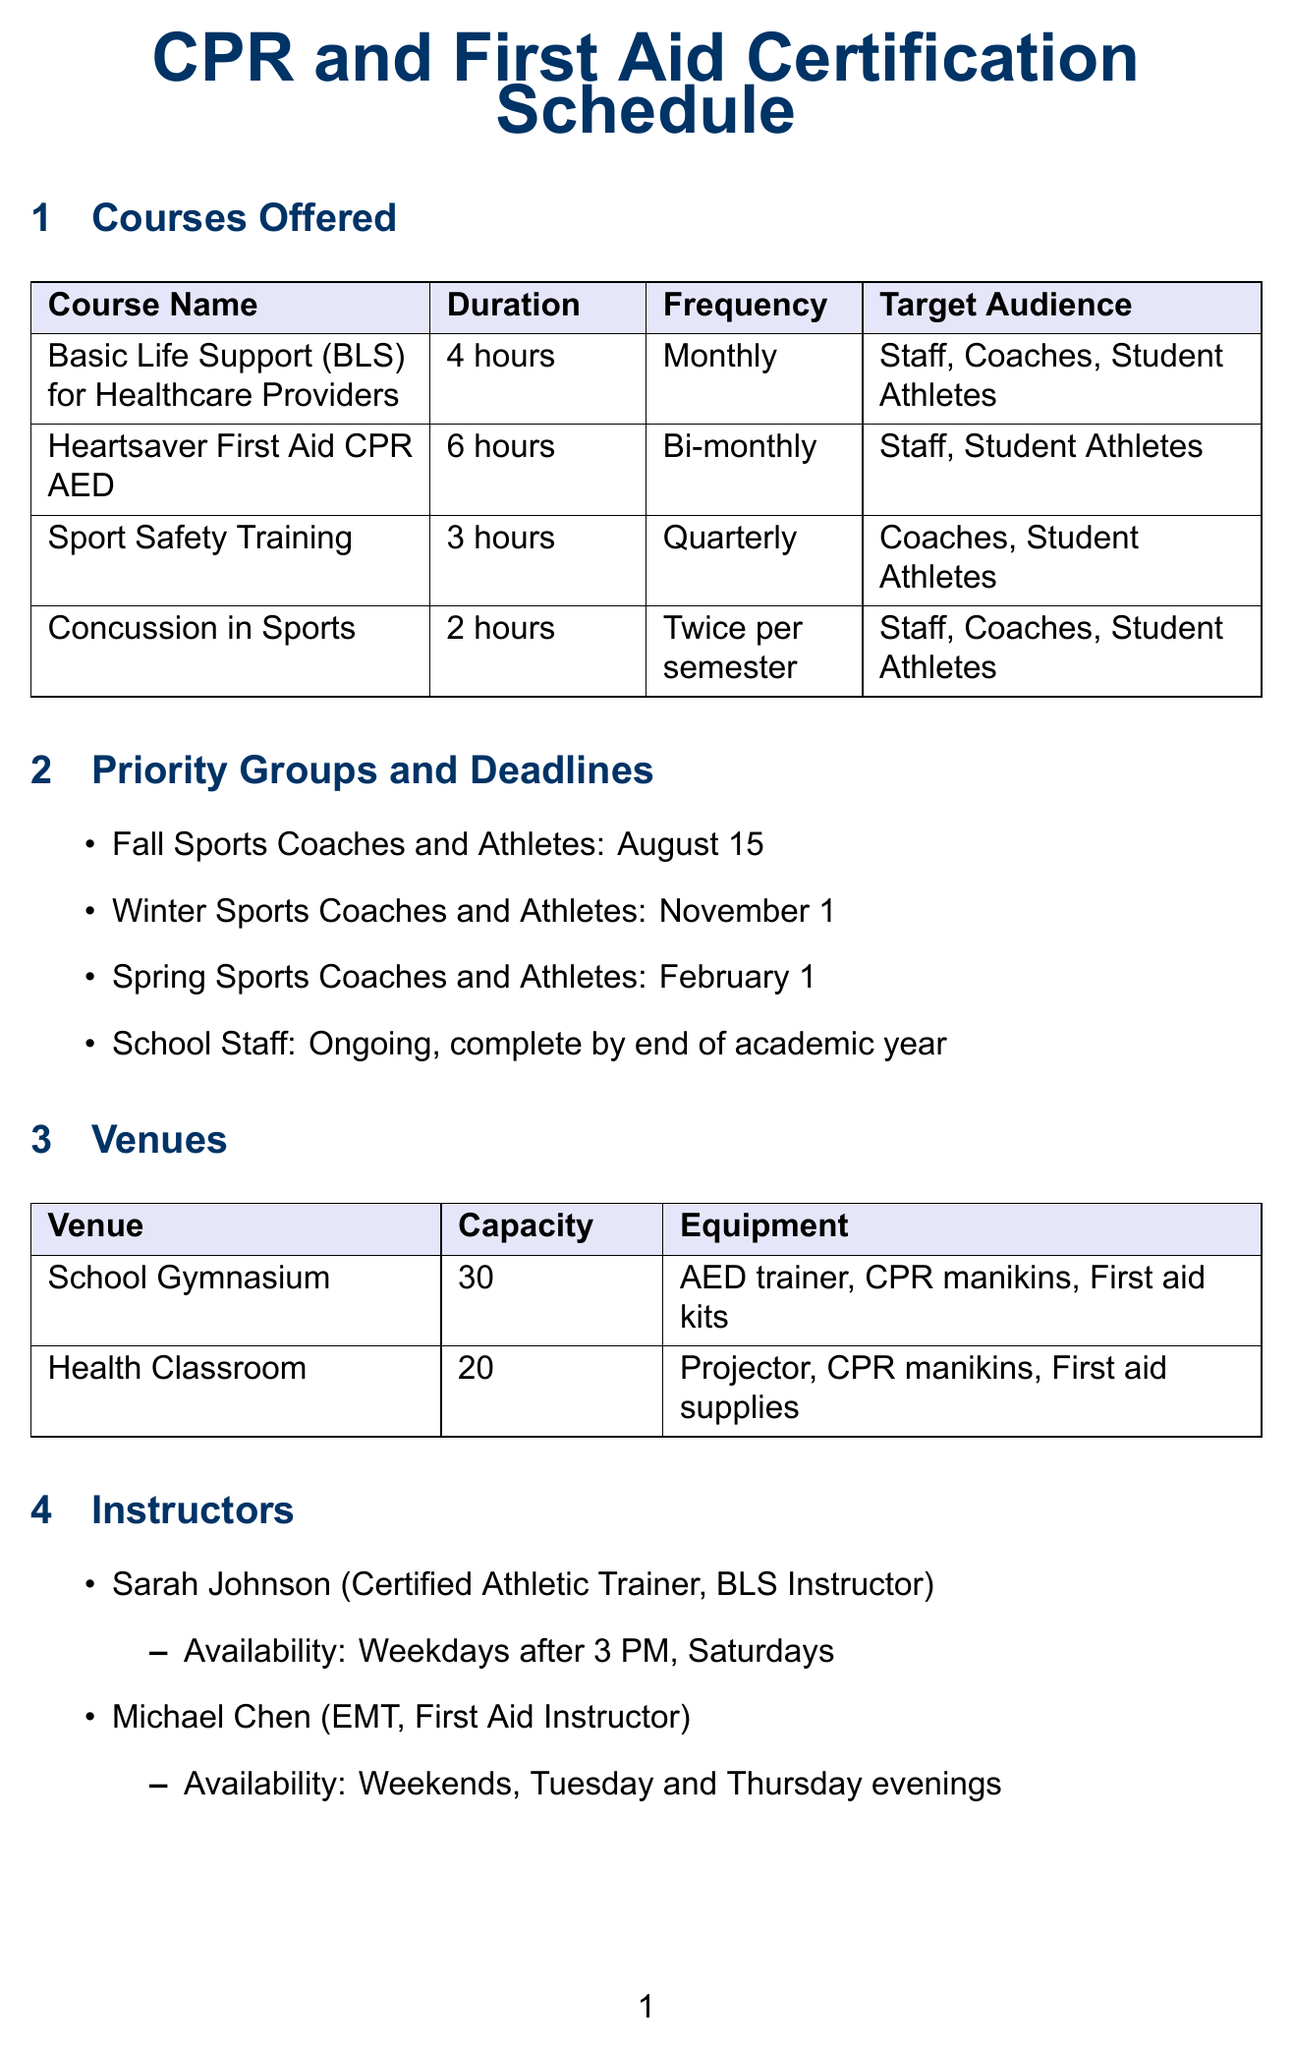What is the maximum number of participants for the Heartsaver course? The maximum number of participants for the Heartsaver First Aid CPR AED course is specified in the document as 15.
Answer: 15 What is the duration of the Sport Safety Training course? The duration of the Sport Safety Training course is clearly stated in the document as 3 hours.
Answer: 3 hours When is the certification deadline for Winter Sports Coaches and Athletes? The certification deadline for Winter Sports Coaches and Athletes is detailed in the document as November 1.
Answer: November 1 How often is the Basic Life Support course offered? The frequency of the Basic Life Support course is mentioned in the document, indicating it is offered monthly.
Answer: Monthly Who is the instructor available on weekends? The document lists Michael Chen as the instructor available on weekends, providing a clear answer.
Answer: Michael Chen What is the total budget allocated for CPR and First Aid certification courses? The total budget is stated in the document, allowing for a straightforward retrieval of the financial figure.
Answer: 5000 Which venue has equipment specifically for CPR manikins? Both the School Gymnasium and the Health Classroom have CPR manikins as part of their equipment, according to the document.
Answer: School Gymnasium, Health Classroom How many times per semester is the Concussion in Sports course offered? The frequency of the Concussion in Sports course is noted in the document as twice per semester.
Answer: Twice per semester 